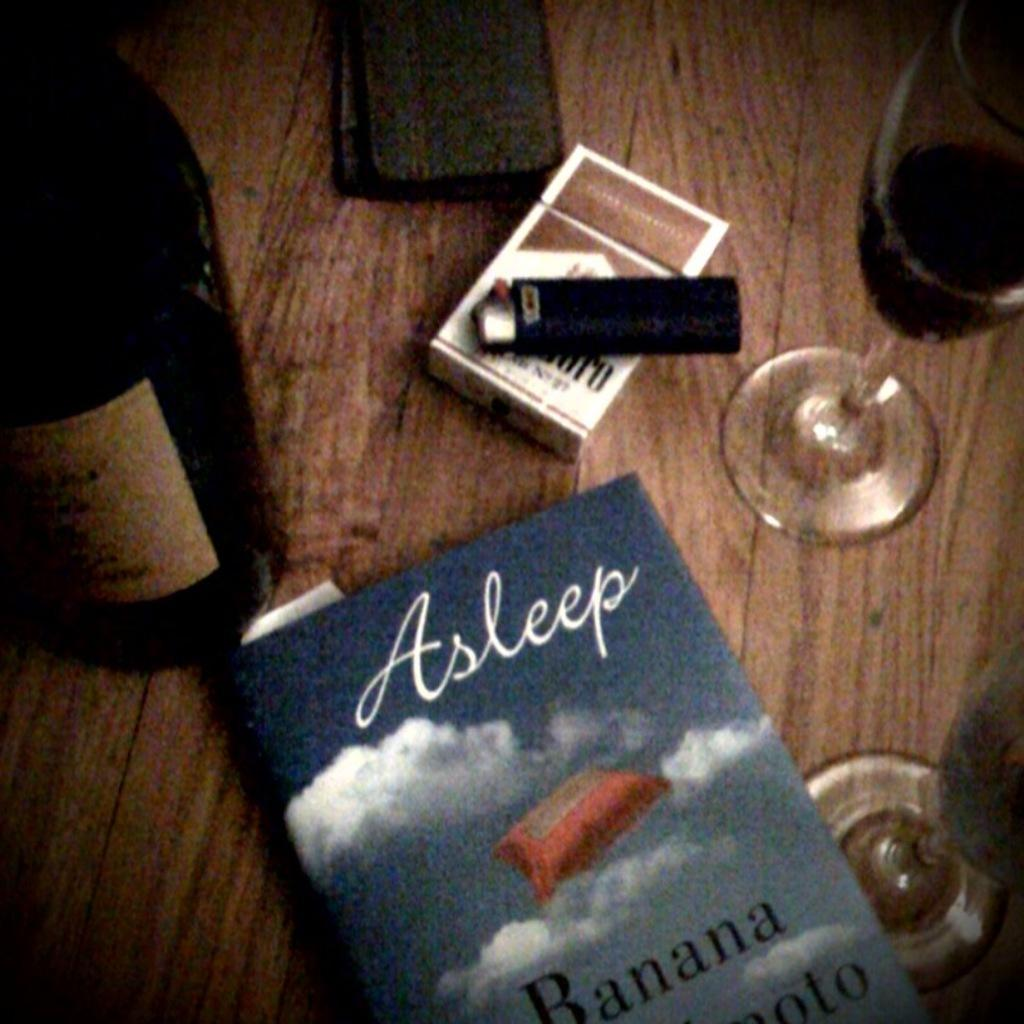<image>
Provide a brief description of the given image. Book titled "Asleep" showing a pillow in the clouds on the cover. 